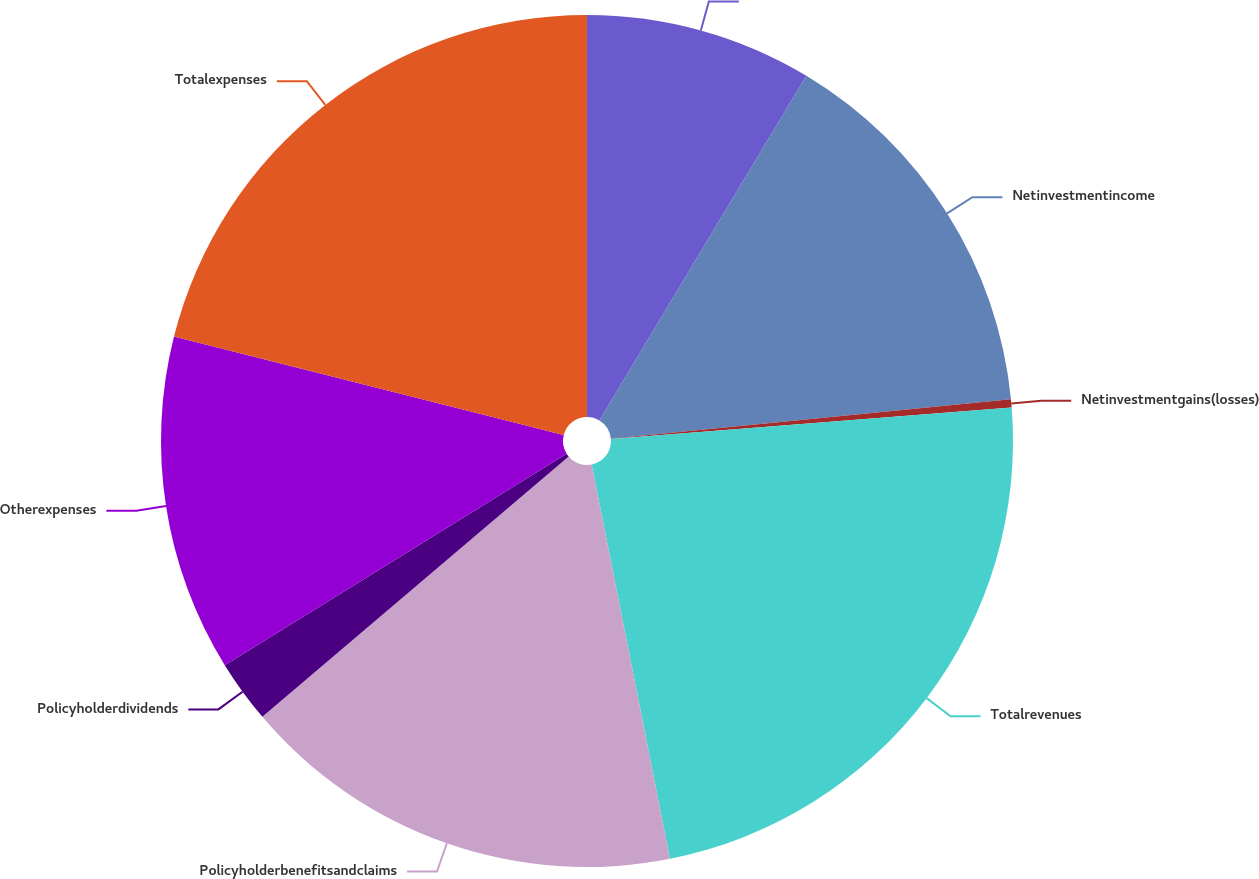Convert chart to OTSL. <chart><loc_0><loc_0><loc_500><loc_500><pie_chart><ecel><fcel>Netinvestmentincome<fcel>Netinvestmentgains(losses)<fcel>Totalrevenues<fcel>Policyholderbenefitsandclaims<fcel>Policyholderdividends<fcel>Otherexpenses<fcel>Totalexpenses<nl><fcel>8.61%<fcel>14.83%<fcel>0.31%<fcel>23.13%<fcel>16.91%<fcel>2.39%<fcel>12.76%<fcel>21.06%<nl></chart> 